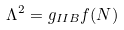Convert formula to latex. <formula><loc_0><loc_0><loc_500><loc_500>\Lambda ^ { 2 } = g _ { I I B } f ( N )</formula> 